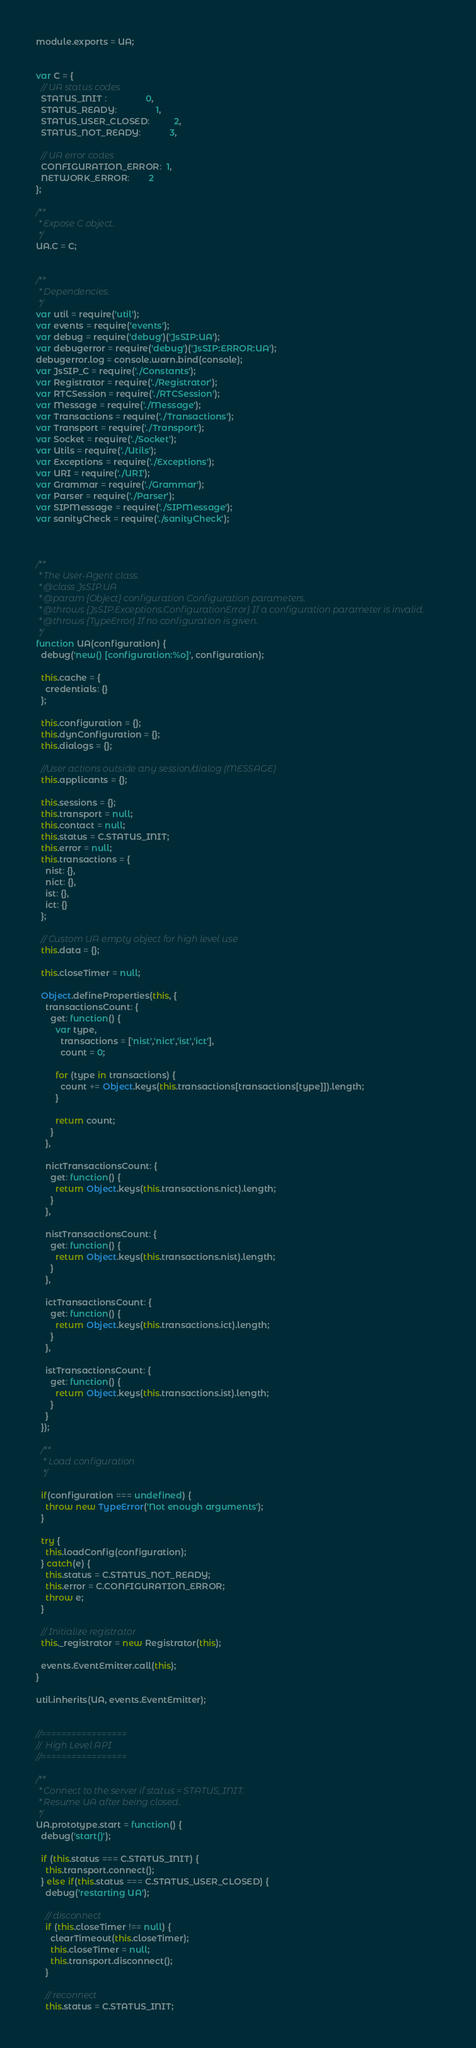<code> <loc_0><loc_0><loc_500><loc_500><_JavaScript_>module.exports = UA;


var C = {
  // UA status codes
  STATUS_INIT :                0,
  STATUS_READY:                1,
  STATUS_USER_CLOSED:          2,
  STATUS_NOT_READY:            3,

  // UA error codes
  CONFIGURATION_ERROR:  1,
  NETWORK_ERROR:        2
};

/**
 * Expose C object.
 */
UA.C = C;


/**
 * Dependencies.
 */
var util = require('util');
var events = require('events');
var debug = require('debug')('JsSIP:UA');
var debugerror = require('debug')('JsSIP:ERROR:UA');
debugerror.log = console.warn.bind(console);
var JsSIP_C = require('./Constants');
var Registrator = require('./Registrator');
var RTCSession = require('./RTCSession');
var Message = require('./Message');
var Transactions = require('./Transactions');
var Transport = require('./Transport');
var Socket = require('./Socket');
var Utils = require('./Utils');
var Exceptions = require('./Exceptions');
var URI = require('./URI');
var Grammar = require('./Grammar');
var Parser = require('./Parser');
var SIPMessage = require('./SIPMessage');
var sanityCheck = require('./sanityCheck');



/**
 * The User-Agent class.
 * @class JsSIP.UA
 * @param {Object} configuration Configuration parameters.
 * @throws {JsSIP.Exceptions.ConfigurationError} If a configuration parameter is invalid.
 * @throws {TypeError} If no configuration is given.
 */
function UA(configuration) {
  debug('new() [configuration:%o]', configuration);

  this.cache = {
    credentials: {}
  };

  this.configuration = {};
  this.dynConfiguration = {};
  this.dialogs = {};

  //User actions outside any session/dialog (MESSAGE)
  this.applicants = {};

  this.sessions = {};
  this.transport = null;
  this.contact = null;
  this.status = C.STATUS_INIT;
  this.error = null;
  this.transactions = {
    nist: {},
    nict: {},
    ist: {},
    ict: {}
  };

  // Custom UA empty object for high level use
  this.data = {};

  this.closeTimer = null;

  Object.defineProperties(this, {
    transactionsCount: {
      get: function() {
        var type,
          transactions = ['nist','nict','ist','ict'],
          count = 0;

        for (type in transactions) {
          count += Object.keys(this.transactions[transactions[type]]).length;
        }

        return count;
      }
    },

    nictTransactionsCount: {
      get: function() {
        return Object.keys(this.transactions.nict).length;
      }
    },

    nistTransactionsCount: {
      get: function() {
        return Object.keys(this.transactions.nist).length;
      }
    },

    ictTransactionsCount: {
      get: function() {
        return Object.keys(this.transactions.ict).length;
      }
    },

    istTransactionsCount: {
      get: function() {
        return Object.keys(this.transactions.ist).length;
      }
    }
  });

  /**
   * Load configuration
   */

  if(configuration === undefined) {
    throw new TypeError('Not enough arguments');
  }

  try {
    this.loadConfig(configuration);
  } catch(e) {
    this.status = C.STATUS_NOT_READY;
    this.error = C.CONFIGURATION_ERROR;
    throw e;
  }

  // Initialize registrator
  this._registrator = new Registrator(this);

  events.EventEmitter.call(this);
}

util.inherits(UA, events.EventEmitter);


//=================
//  High Level API
//=================

/**
 * Connect to the server if status = STATUS_INIT.
 * Resume UA after being closed.
 */
UA.prototype.start = function() {
  debug('start()');

  if (this.status === C.STATUS_INIT) {
    this.transport.connect();
  } else if(this.status === C.STATUS_USER_CLOSED) {
    debug('restarting UA');

    // disconnect
    if (this.closeTimer !== null) {
      clearTimeout(this.closeTimer);
      this.closeTimer = null;
      this.transport.disconnect();
    }

    // reconnect
    this.status = C.STATUS_INIT;</code> 